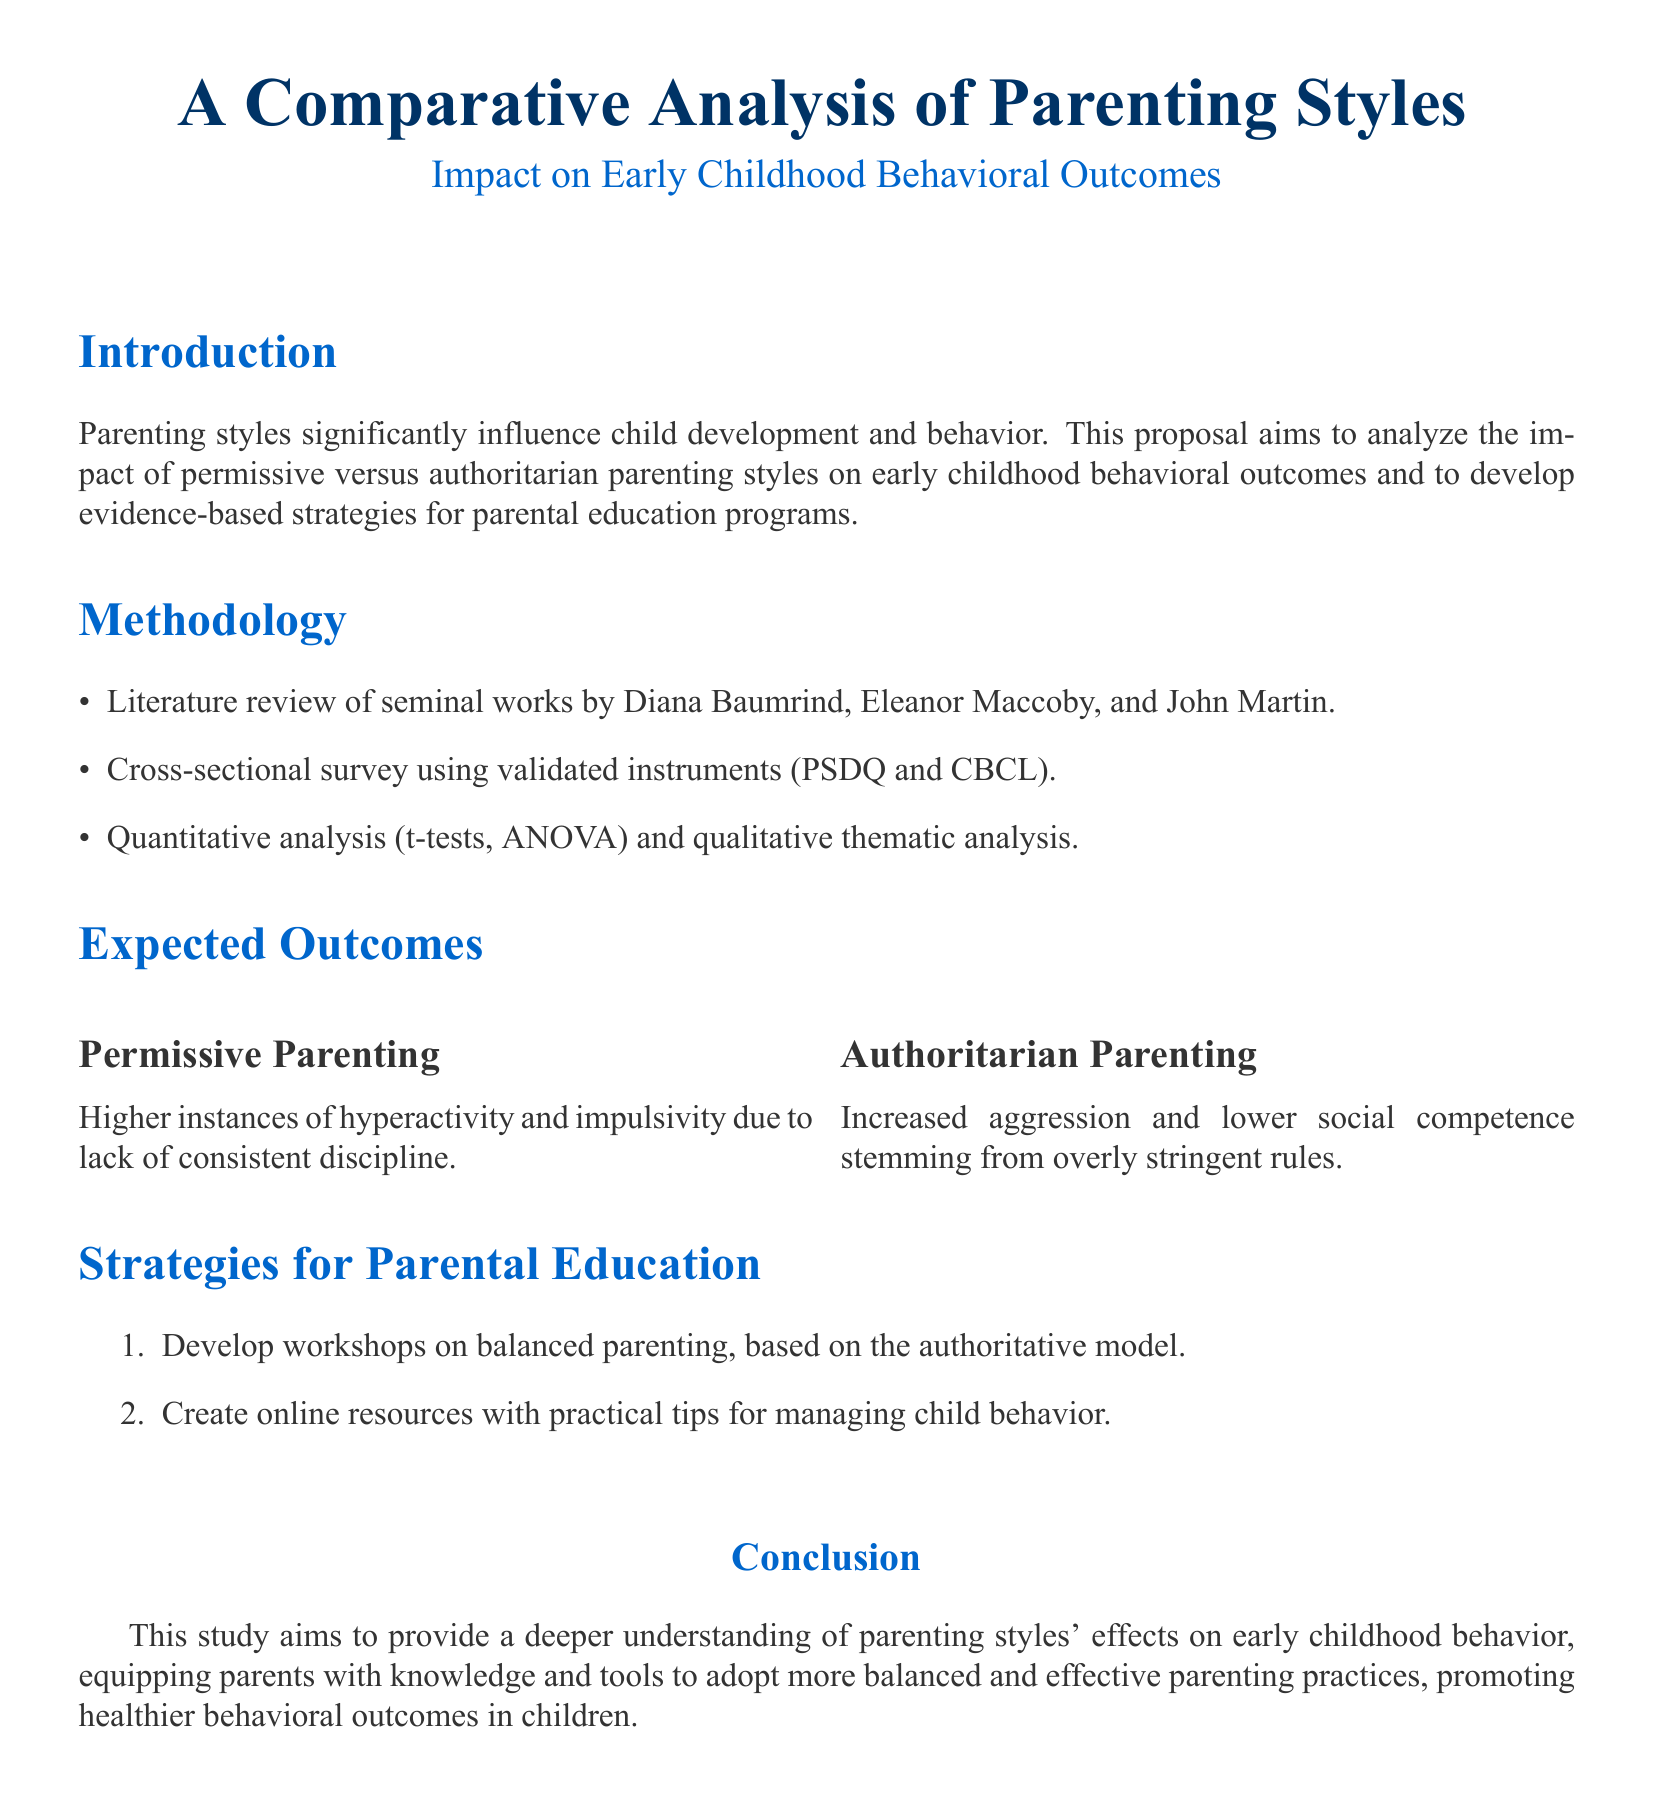What is the main focus of the proposal? The main focus of the proposal is to analyze the impact of different parenting styles on child behavior and develop parenting education strategies.
Answer: impact on early childhood behavioral outcomes Who are the key authors referenced in the literature review? The key authors referenced are influential figures in the field of parenting styles.
Answer: Diana Baumrind, Eleanor Maccoby, John Martin What methodology will be used in the study? The methodology includes several approaches for data collection and analysis.
Answer: Literature review, cross-sectional survey, quantitative and qualitative analysis What is one expected outcome of permissive parenting? This refers to child behaviors associated with permissive parenting.
Answer: Hyperactivity and impulsivity What strategy is suggested for parental education? This refers to a specific approach proposed for educating parents.
Answer: Develop workshops on balanced parenting, based on the authoritative model What statistical methods are mentioned for analysis? This refers to the types of statistical analyses that will be performed on the collected data.
Answer: t-tests, ANOVA What is the purpose of this study according to the conclusion? This summarizes the overall intent behind conducting the study.
Answer: Provide a deeper understanding of parenting styles' effects on early childhood behavior What type of analysis will be conducted in the study? This specifies the nature of the analysis performed on the collected data.
Answer: Quantitative analysis and qualitative thematic analysis 